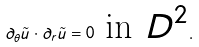Convert formula to latex. <formula><loc_0><loc_0><loc_500><loc_500>\partial _ { \theta } \tilde { u } \cdot \partial _ { r } \tilde { u } = 0 \text { in $D^{2}$} .</formula> 